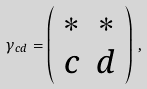Convert formula to latex. <formula><loc_0><loc_0><loc_500><loc_500>\gamma _ { c d } = \left ( \begin{array} { c c } * & * \\ c & d \end{array} \right ) \, ,</formula> 